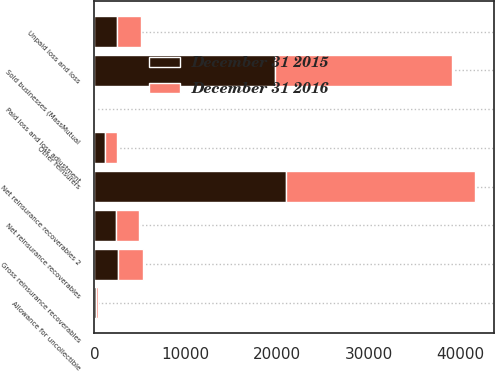Convert chart to OTSL. <chart><loc_0><loc_0><loc_500><loc_500><stacked_bar_chart><ecel><fcel>Paid loss and loss adjustment<fcel>Unpaid loss and loss<fcel>Gross reinsurance recoverables<fcel>Allowance for uncollectible<fcel>Net reinsurance recoverables<fcel>Sold businesses (MassMutual<fcel>Other reinsurers<fcel>Net reinsurance recoverables 2<nl><fcel>December 31 2015<fcel>89<fcel>2449<fcel>2538<fcel>165<fcel>2373<fcel>19729<fcel>1209<fcel>20938<nl><fcel>December 31 2016<fcel>119<fcel>2662<fcel>2781<fcel>266<fcel>2515<fcel>19369<fcel>1305<fcel>20674<nl></chart> 